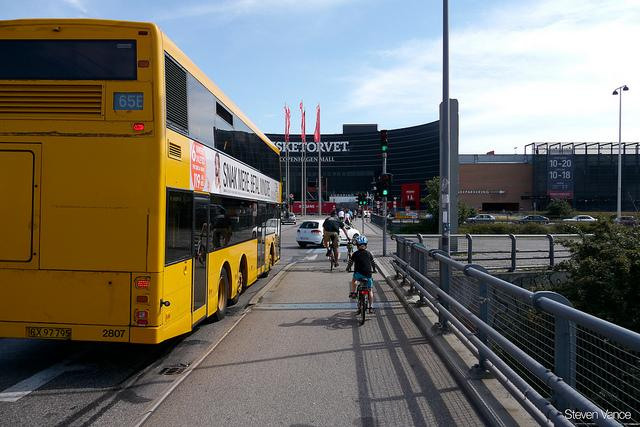What is the full name of the building ahead?

Choices:
A) basketorvet
B) husketorvet
C) kesketorvet
D) fisketorvet fisketorvet 